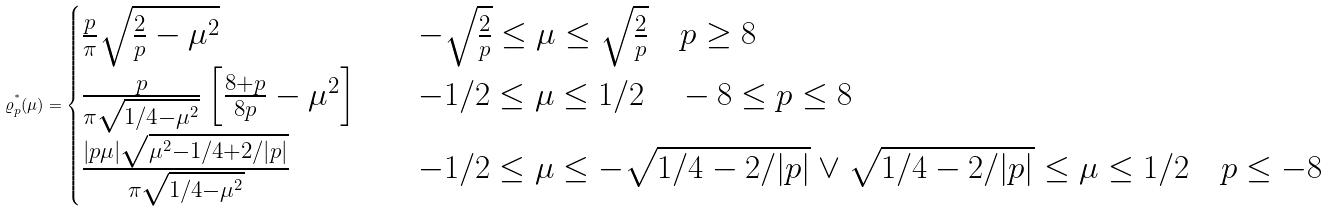Convert formula to latex. <formula><loc_0><loc_0><loc_500><loc_500>\varrho _ { p } ^ { ^ { * } } ( \mu ) = \begin{cases} \frac { p } { \pi } \sqrt { \frac { 2 } { p } - { \mu } ^ { 2 } } & \quad - \sqrt { \frac { 2 } { p } } \leq \mu \leq \sqrt { \frac { 2 } { p } } \quad p \geq 8 \\ \frac { p } { \pi \sqrt { 1 / 4 - { \mu } ^ { 2 } } } \left [ \frac { 8 + p } { 8 p } - { \mu } ^ { 2 } \right ] & \quad - 1 / 2 \leq \mu \leq 1 / 2 \quad - 8 \leq p \leq 8 \\ \frac { | p \mu | \sqrt { { \mu } ^ { 2 } - 1 / 4 + 2 / | p | } } { \pi \sqrt { 1 / 4 - { \mu } ^ { 2 } } } & \quad - 1 / 2 \leq \mu \leq - \sqrt { 1 / 4 - 2 / | p | } \vee \sqrt { 1 / 4 - 2 / | p | } \leq \mu \leq 1 / 2 \quad p \leq - 8 \end{cases}</formula> 